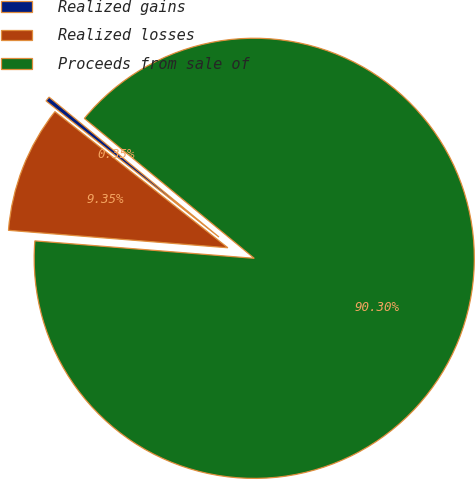Convert chart. <chart><loc_0><loc_0><loc_500><loc_500><pie_chart><fcel>Realized gains<fcel>Realized losses<fcel>Proceeds from sale of<nl><fcel>0.35%<fcel>9.35%<fcel>90.3%<nl></chart> 